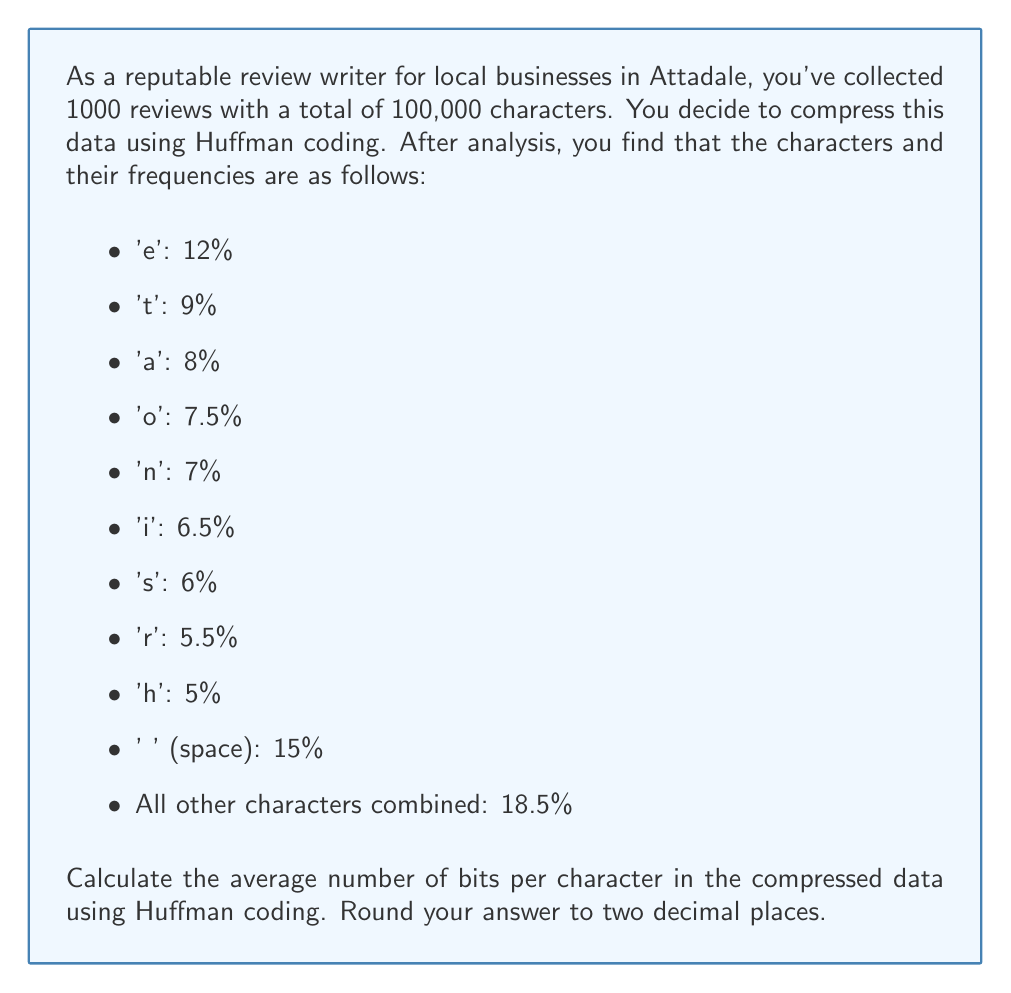Solve this math problem. To solve this problem, we'll follow these steps:

1. Construct the Huffman tree (conceptually)
2. Determine the length of each character's Huffman code
3. Calculate the weighted average of code lengths

Step 1: Constructing the Huffman tree
We don't need to actually draw the tree, but we can determine the code lengths based on the frequencies.

Step 2: Determining code lengths
The Huffman code length for each character is approximately $-\log_2(p)$, where $p$ is the probability (frequency) of the character. We'll calculate this for each character:

- ' ' (space): $-\log_2(0.15) \approx 2.74$ bits
- 'e': $-\log_2(0.12) \approx 3.06$ bits
- 't': $-\log_2(0.09) \approx 3.47$ bits
- 'a': $-\log_2(0.08) \approx 3.64$ bits
- 'o': $-\log_2(0.075) \approx 3.74$ bits
- 'n': $-\log_2(0.07) \approx 3.84$ bits
- 'i': $-\log_2(0.065) \approx 3.94$ bits
- 's': $-\log_2(0.06) \approx 4.06$ bits
- 'r': $-\log_2(0.055) \approx 4.18$ bits
- 'h': $-\log_2(0.05) \approx 4.32$ bits
- Others: $-\log_2(0.185) \approx 2.43$ bits

Step 3: Calculating the weighted average
We multiply each code length by its frequency and sum the results:

$$\begin{align}
\text{Average} &= (2.74 \times 0.15) + (3.06 \times 0.12) + (3.47 \times 0.09) + (3.64 \times 0.08) \\
&+ (3.74 \times 0.075) + (3.84 \times 0.07) + (3.94 \times 0.065) + (4.06 \times 0.06) \\
&+ (4.18 \times 0.055) + (4.32 \times 0.05) + (2.43 \times 0.185) \\
&\approx 3.3374 \text{ bits per character}
\end{align}$$

Rounding to two decimal places, we get 3.34 bits per character.
Answer: 3.34 bits per character 